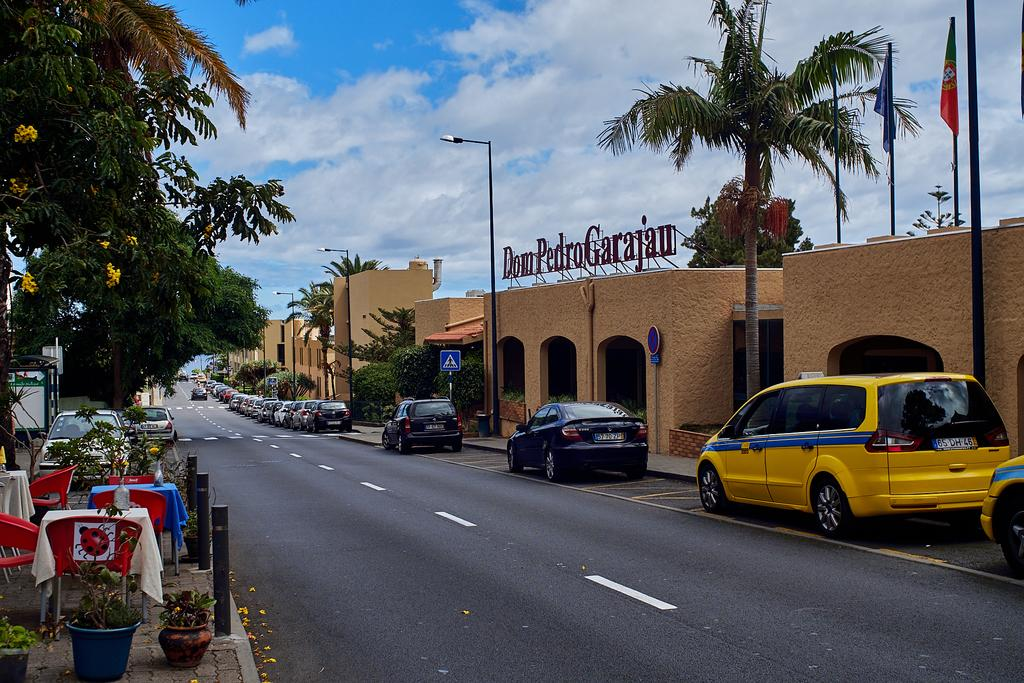<image>
Relay a brief, clear account of the picture shown. A number of cars are parked on the street in front of Don Pedro Garajan. 